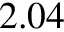<formula> <loc_0><loc_0><loc_500><loc_500>2 . 0 4</formula> 